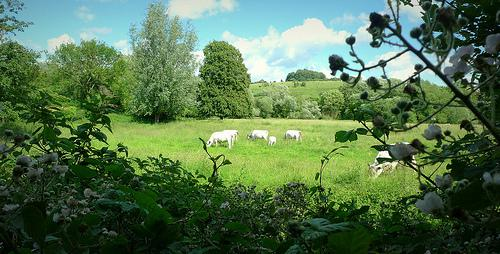Question: what animals are shown?
Choices:
A. Sheep.
B. Cows.
C. Goats.
D. Pigs.
Answer with the letter. Answer: A Question: how is the weather?
Choices:
A. Windy.
B. Sunny.
C. Rainy.
D. Snowy.
Answer with the letter. Answer: B Question: what are the sheep doing?
Choices:
A. Eating.
B. Feeding.
C. Grazing.
D. Standing.
Answer with the letter. Answer: C Question: what color are the sheep?
Choices:
A. Blue.
B. White.
C. Green.
D. Orange.
Answer with the letter. Answer: B Question: what is in the background?
Choices:
A. Mountains.
B. Clouds.
C. Trees.
D. Ocean.
Answer with the letter. Answer: C Question: where was this picture taken?
Choices:
A. A yard.
B. The woods.
C. A field.
D. The plains.
Answer with the letter. Answer: C 